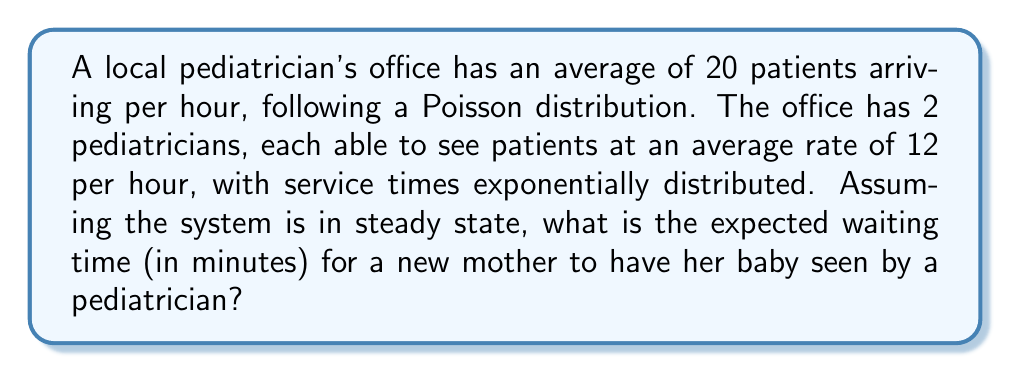Give your solution to this math problem. To solve this problem, we'll use the M/M/2 queueing model:

1. Identify the parameters:
   - Arrival rate: $\lambda = 20$ patients/hour
   - Service rate per server: $\mu = 12$ patients/hour
   - Number of servers: $s = 2$

2. Calculate the utilization factor $\rho$:
   $$\rho = \frac{\lambda}{s\mu} = \frac{20}{2 \cdot 12} = \frac{5}{6} \approx 0.833$$

3. Calculate $P_0$, the probability of an empty system:
   $$P_0 = \left[\sum_{n=0}^{s-1}\frac{(s\rho)^n}{n!} + \frac{(s\rho)^s}{s!(1-\rho)}\right]^{-1}$$
   $$P_0 = \left[1 + \frac{20}{1!} + \frac{20^2}{2!(1-\frac{5}{6})}\right]^{-1} \approx 0.0323$$

4. Calculate $L_q$, the expected number of patients in the queue:
   $$L_q = \frac{P_0(s\rho)^s\rho}{s!(1-\rho)^2} = \frac{0.0323 \cdot 20^2 \cdot \frac{5}{6}}{2!(1-\frac{5}{6})^2} \approx 4.1667$$

5. Use Little's Law to find $W_q$, the expected waiting time in the queue:
   $$W_q = \frac{L_q}{\lambda} = \frac{4.1667}{20} = 0.20833 \text{ hours}$$

6. Convert the waiting time to minutes:
   $$W_q \text{ (in minutes)} = 0.20833 \cdot 60 = 12.5 \text{ minutes}$$
Answer: 12.5 minutes 